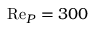<formula> <loc_0><loc_0><loc_500><loc_500>R e _ { P } = 3 0 0</formula> 